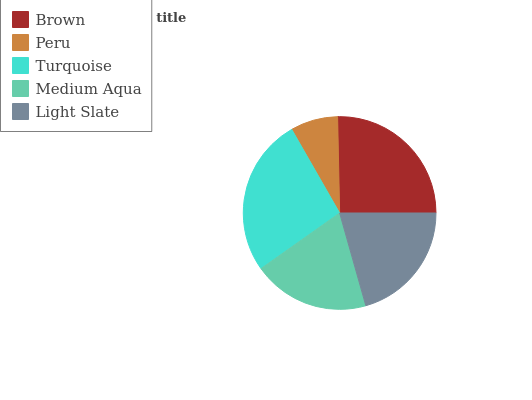Is Peru the minimum?
Answer yes or no. Yes. Is Turquoise the maximum?
Answer yes or no. Yes. Is Turquoise the minimum?
Answer yes or no. No. Is Peru the maximum?
Answer yes or no. No. Is Turquoise greater than Peru?
Answer yes or no. Yes. Is Peru less than Turquoise?
Answer yes or no. Yes. Is Peru greater than Turquoise?
Answer yes or no. No. Is Turquoise less than Peru?
Answer yes or no. No. Is Light Slate the high median?
Answer yes or no. Yes. Is Light Slate the low median?
Answer yes or no. Yes. Is Peru the high median?
Answer yes or no. No. Is Brown the low median?
Answer yes or no. No. 